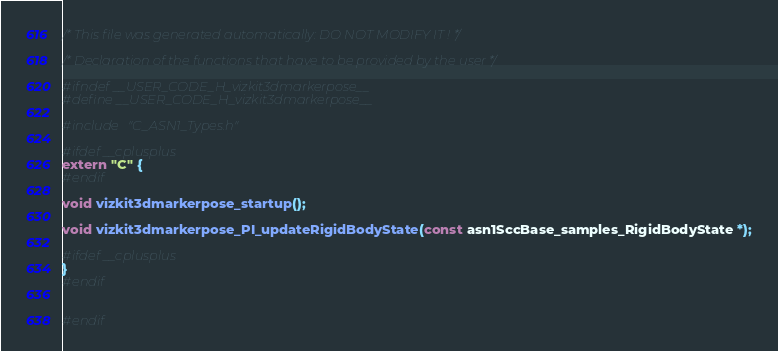<code> <loc_0><loc_0><loc_500><loc_500><_C_>/* This file was generated automatically: DO NOT MODIFY IT ! */

/* Declaration of the functions that have to be provided by the user */

#ifndef __USER_CODE_H_vizkit3dmarkerpose__
#define __USER_CODE_H_vizkit3dmarkerpose__

#include "C_ASN1_Types.h"

#ifdef __cplusplus
extern "C" {
#endif

void vizkit3dmarkerpose_startup();

void vizkit3dmarkerpose_PI_updateRigidBodyState(const asn1SccBase_samples_RigidBodyState *);

#ifdef __cplusplus
}
#endif


#endif
</code> 